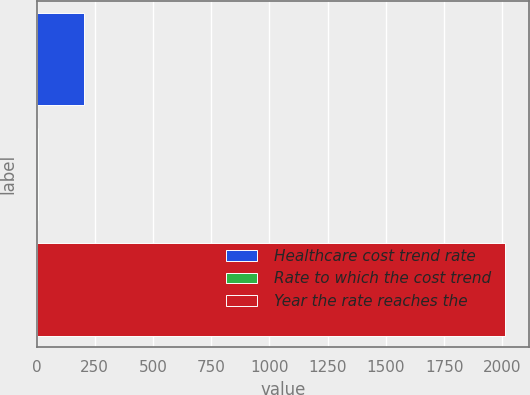<chart> <loc_0><loc_0><loc_500><loc_500><bar_chart><fcel>Healthcare cost trend rate<fcel>Rate to which the cost trend<fcel>Year the rate reaches the<nl><fcel>205.8<fcel>5<fcel>2013<nl></chart> 